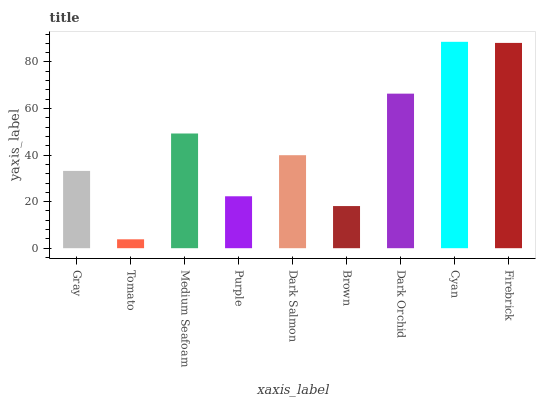Is Tomato the minimum?
Answer yes or no. Yes. Is Cyan the maximum?
Answer yes or no. Yes. Is Medium Seafoam the minimum?
Answer yes or no. No. Is Medium Seafoam the maximum?
Answer yes or no. No. Is Medium Seafoam greater than Tomato?
Answer yes or no. Yes. Is Tomato less than Medium Seafoam?
Answer yes or no. Yes. Is Tomato greater than Medium Seafoam?
Answer yes or no. No. Is Medium Seafoam less than Tomato?
Answer yes or no. No. Is Dark Salmon the high median?
Answer yes or no. Yes. Is Dark Salmon the low median?
Answer yes or no. Yes. Is Purple the high median?
Answer yes or no. No. Is Cyan the low median?
Answer yes or no. No. 